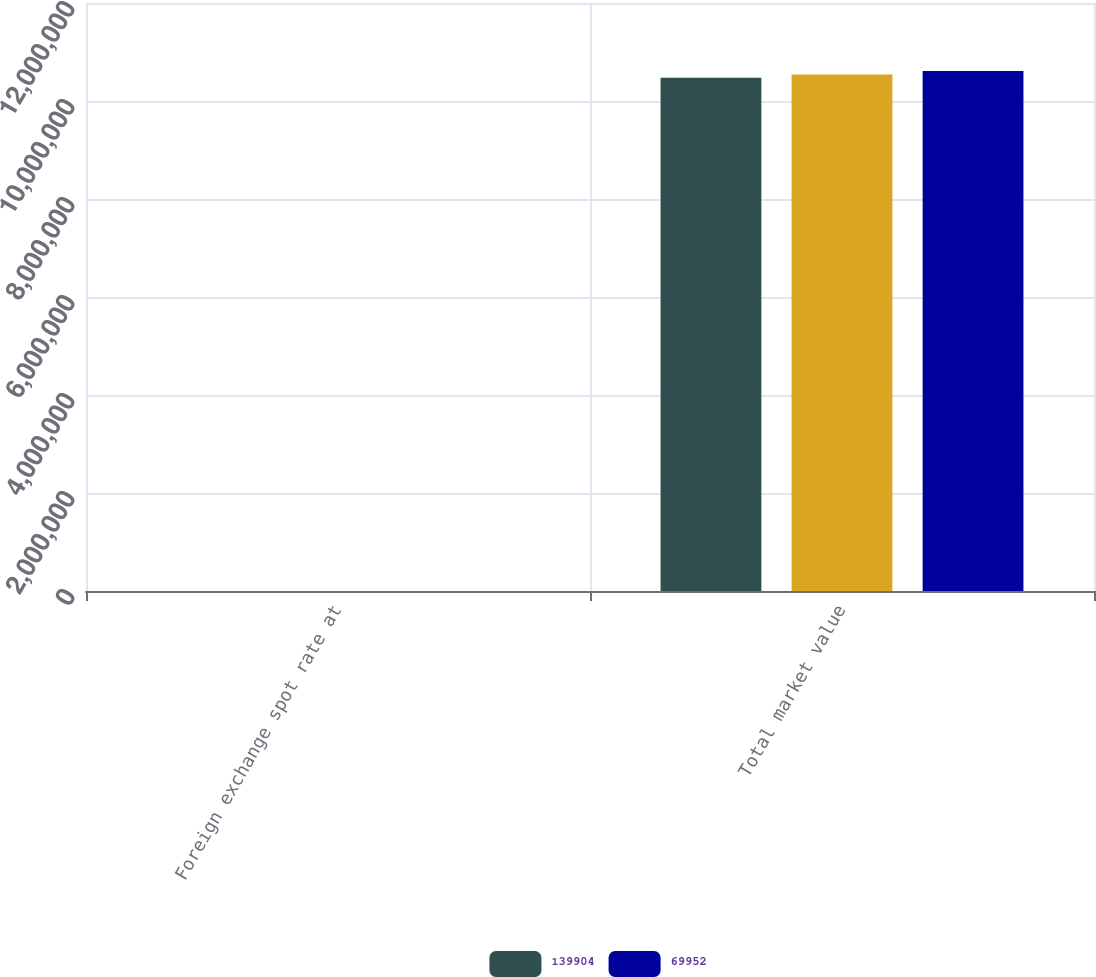<chart> <loc_0><loc_0><loc_500><loc_500><stacked_bar_chart><ecel><fcel>Foreign exchange spot rate at<fcel>Total market value<nl><fcel>139904<fcel>10<fcel>1.04726e+07<nl><fcel>nan<fcel>5<fcel>1.05426e+07<nl><fcel>69952<fcel>0<fcel>1.06126e+07<nl></chart> 